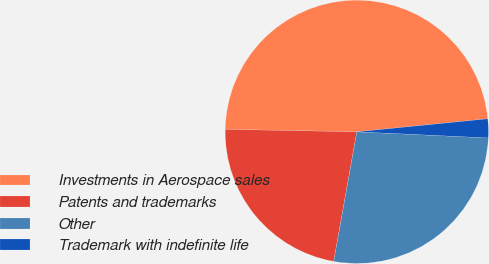Convert chart to OTSL. <chart><loc_0><loc_0><loc_500><loc_500><pie_chart><fcel>Investments in Aerospace sales<fcel>Patents and trademarks<fcel>Other<fcel>Trademark with indefinite life<nl><fcel>48.11%<fcel>22.49%<fcel>27.07%<fcel>2.32%<nl></chart> 